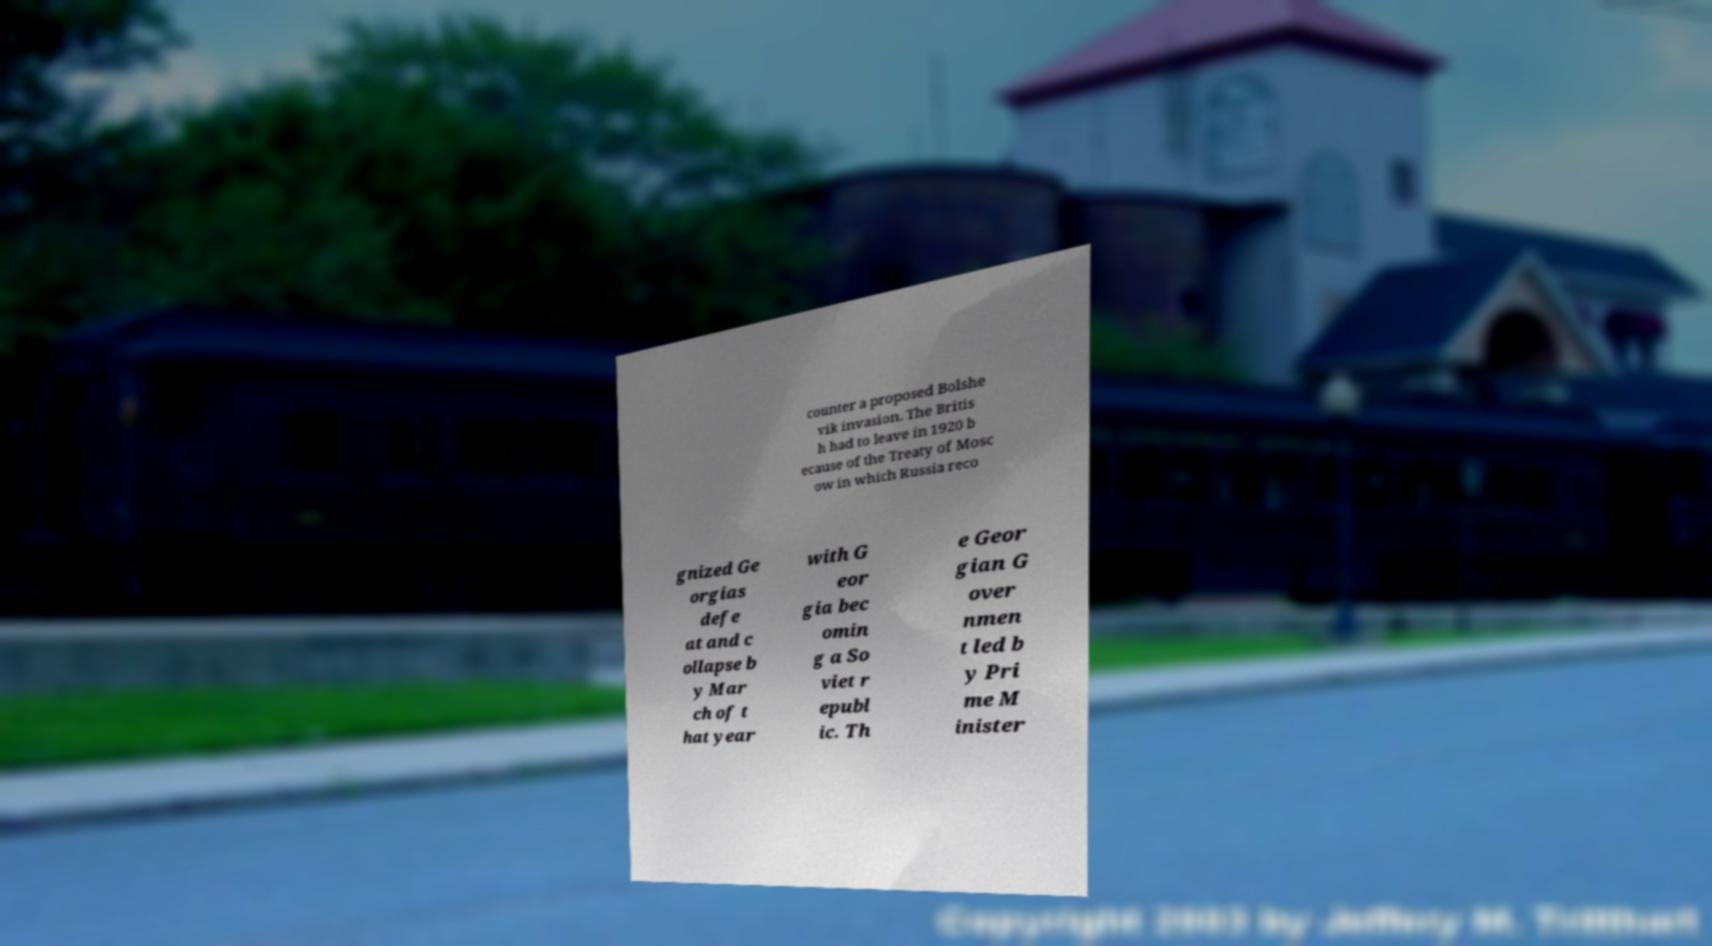Can you accurately transcribe the text from the provided image for me? counter a proposed Bolshe vik invasion. The Britis h had to leave in 1920 b ecause of the Treaty of Mosc ow in which Russia reco gnized Ge orgias defe at and c ollapse b y Mar ch of t hat year with G eor gia bec omin g a So viet r epubl ic. Th e Geor gian G over nmen t led b y Pri me M inister 